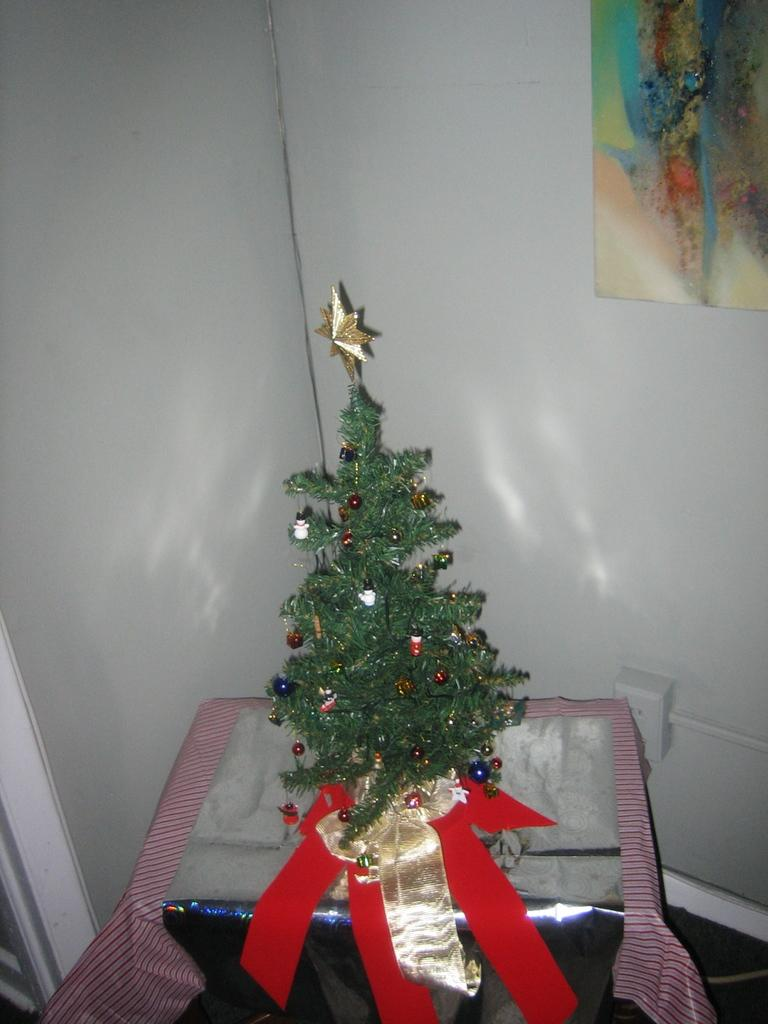What type of tree is in the image? There is a Christmas tree in the image. What can be seen on the Christmas tree? The Christmas tree has decorative items. What is the Christmas tree placed on? The Christmas tree is placed on an object. What other item can be seen in the image? There is a photo frame in the image. Where is the photo frame located? The photo frame is attached to the wall. How many rabbits are sitting on the Christmas tree in the image? There are no rabbits present on the Christmas tree in the image. What type of fruit is hanging from the photo frame in the image? There is no fruit hanging from the photo frame in the image. 